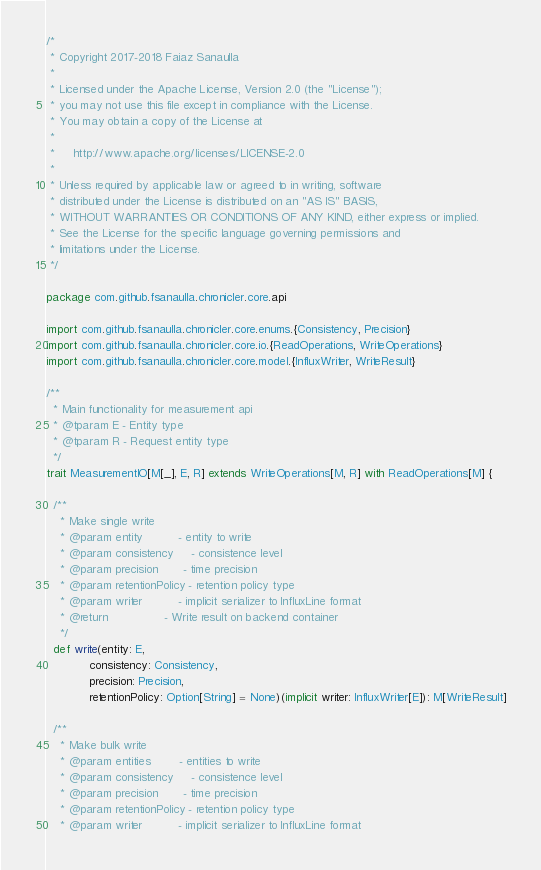Convert code to text. <code><loc_0><loc_0><loc_500><loc_500><_Scala_>/*
 * Copyright 2017-2018 Faiaz Sanaulla
 *
 * Licensed under the Apache License, Version 2.0 (the "License");
 * you may not use this file except in compliance with the License.
 * You may obtain a copy of the License at
 *
 *     http://www.apache.org/licenses/LICENSE-2.0
 *
 * Unless required by applicable law or agreed to in writing, software
 * distributed under the License is distributed on an "AS IS" BASIS,
 * WITHOUT WARRANTIES OR CONDITIONS OF ANY KIND, either express or implied.
 * See the License for the specific language governing permissions and
 * limitations under the License.
 */

package com.github.fsanaulla.chronicler.core.api

import com.github.fsanaulla.chronicler.core.enums.{Consistency, Precision}
import com.github.fsanaulla.chronicler.core.io.{ReadOperations, WriteOperations}
import com.github.fsanaulla.chronicler.core.model.{InfluxWriter, WriteResult}

/**
  * Main functionality for measurement api
  * @tparam E - Entity type
  * @tparam R - Request entity type
  */
trait MeasurementIO[M[_], E, R] extends WriteOperations[M, R] with ReadOperations[M] {

  /**
    * Make single write
    * @param entity          - entity to write
    * @param consistency     - consistence level
    * @param precision       - time precision
    * @param retentionPolicy - retention policy type
    * @param writer          - implicit serializer to InfluxLine format
    * @return                - Write result on backend container
    */
  def write(entity: E,
            consistency: Consistency,
            precision: Precision,
            retentionPolicy: Option[String] = None)(implicit writer: InfluxWriter[E]): M[WriteResult]

  /**
    * Make bulk write
    * @param entities        - entities to write
    * @param consistency     - consistence level
    * @param precision       - time precision
    * @param retentionPolicy - retention policy type
    * @param writer          - implicit serializer to InfluxLine format</code> 